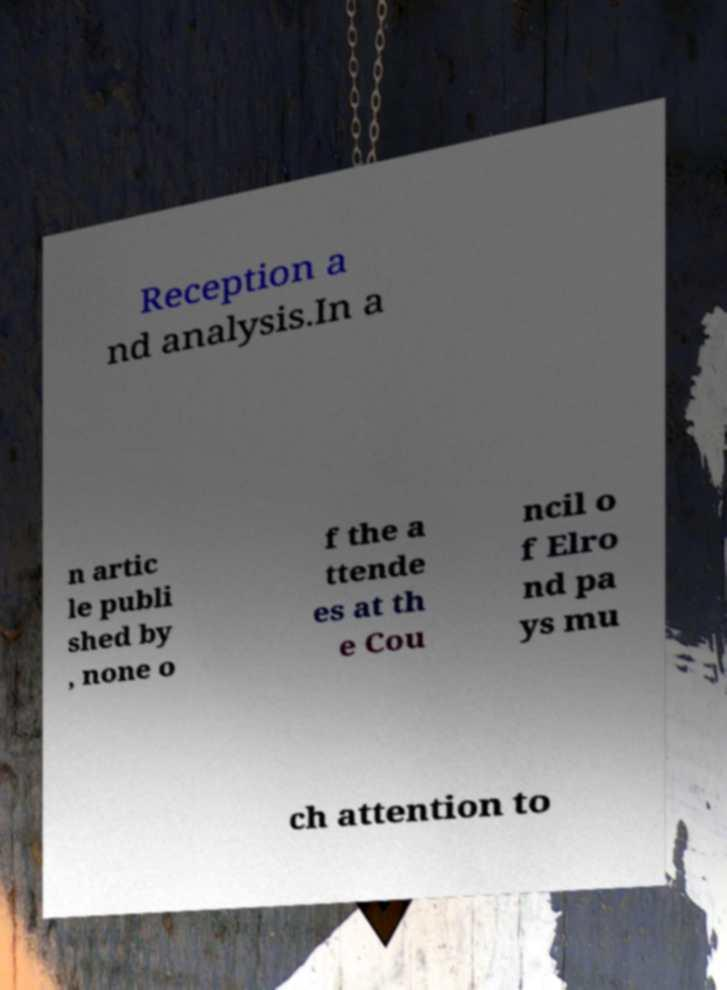Could you extract and type out the text from this image? Reception a nd analysis.In a n artic le publi shed by , none o f the a ttende es at th e Cou ncil o f Elro nd pa ys mu ch attention to 